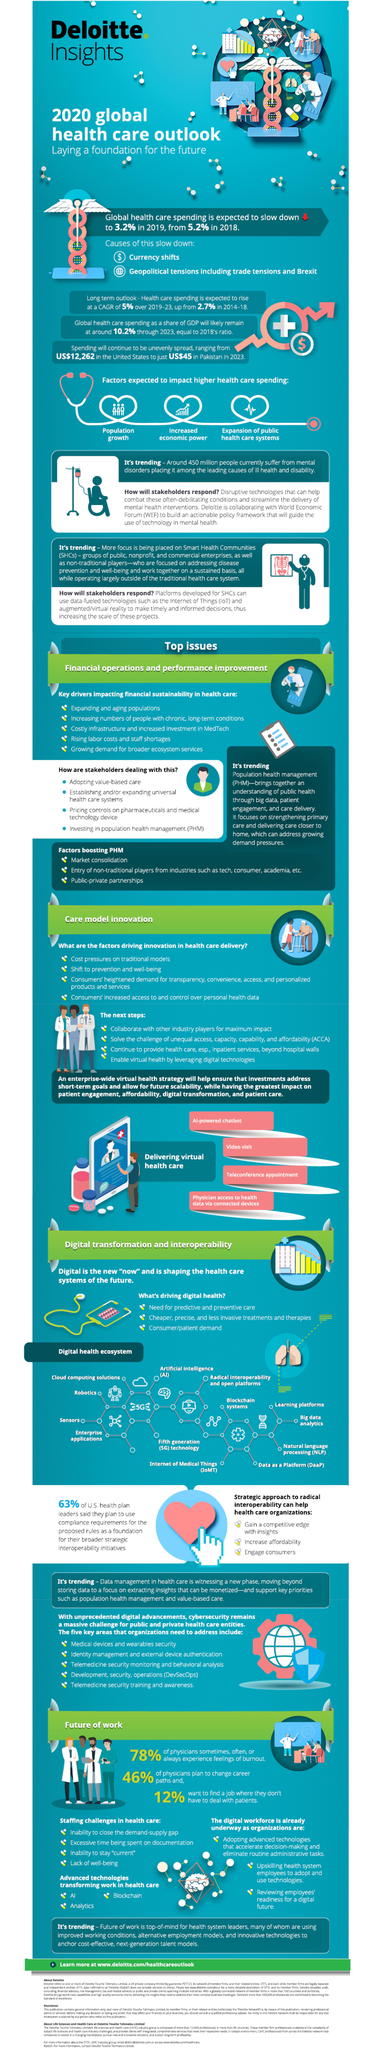Point out several critical features in this image. According to a recent survey, 54% of physicians do not plan to change their career paths. Global health care spending is expected to decline by 2.0% during the years 2018-2019. 